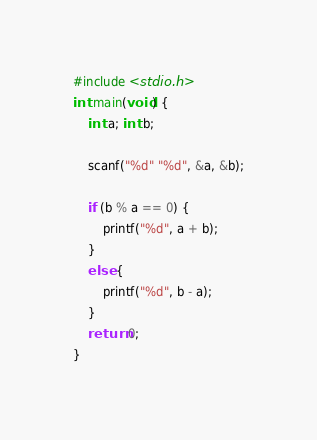Convert code to text. <code><loc_0><loc_0><loc_500><loc_500><_C_>#include <stdio.h>
int main(void) {
	int a; int b;

	scanf("%d" "%d", &a, &b);

	if (b % a == 0) {
		printf("%d", a + b);
	}
	else {
		printf("%d", b - a);
	}
	return 0;
}</code> 